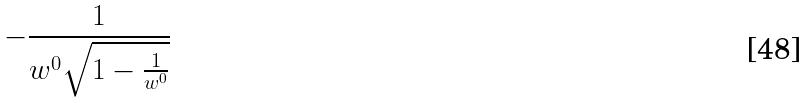Convert formula to latex. <formula><loc_0><loc_0><loc_500><loc_500>- \frac { 1 } { w ^ { 0 } \sqrt { 1 - \frac { 1 } { w ^ { 0 } } } }</formula> 